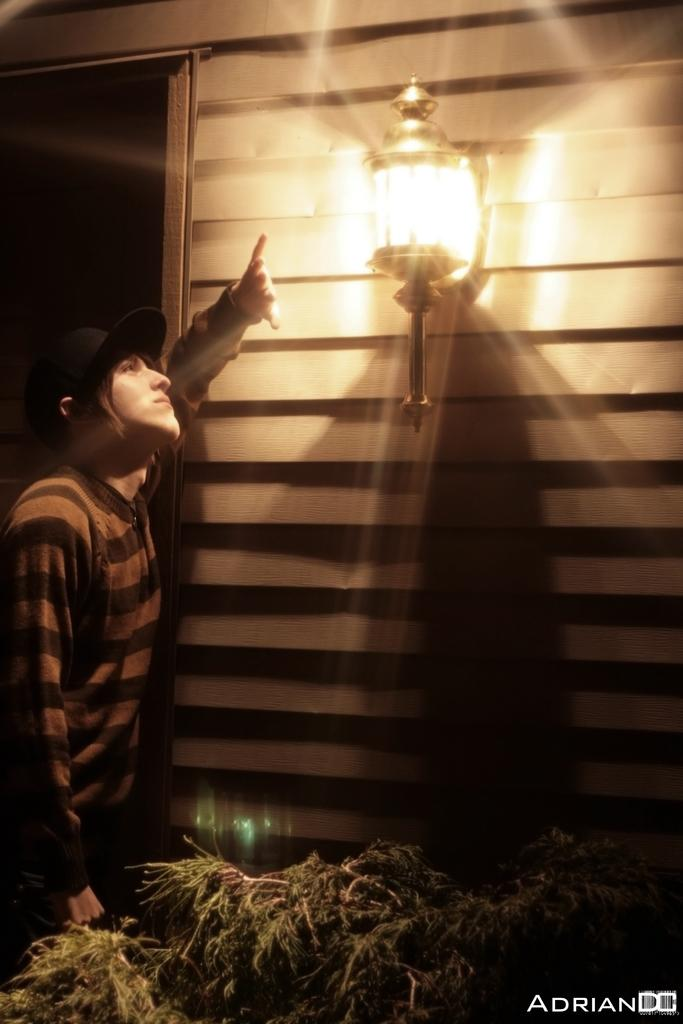What is the main subject of the image? There is a person in the image. What is the person wearing on their upper body? The person is wearing a t-shirt. What type of headwear is the person wearing? The person is wearing a black hat. What is the person's posture in the image? The person is standing. What type of natural element can be seen in the image? There is a tree in the image. What type of man-made structure is present in the image? There is a building in the image. What additional feature can be seen on the building? There is a lamp attached to the building. How many bricks are visible on the person's hat in the image? There are no bricks visible on the person's hat in the image; it is a black hat. Can you tell me how many snails are crawling on the tree in the image? There are no snails present on the tree in the image; only the tree itself is visible. 